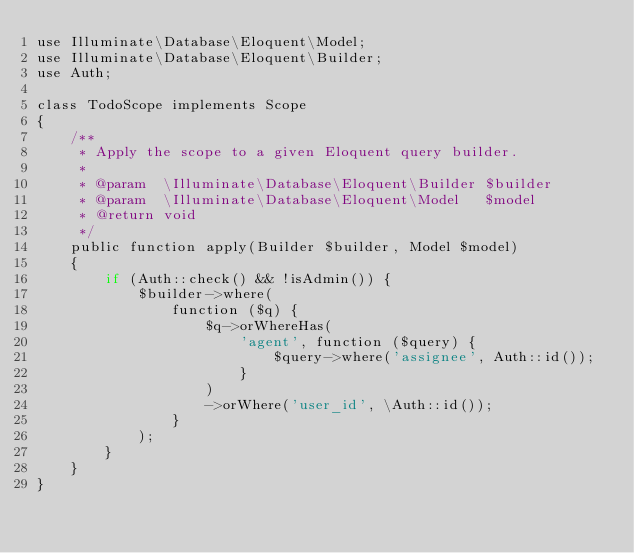Convert code to text. <code><loc_0><loc_0><loc_500><loc_500><_PHP_>use Illuminate\Database\Eloquent\Model;
use Illuminate\Database\Eloquent\Builder;
use Auth;

class TodoScope implements Scope
{
    /**
     * Apply the scope to a given Eloquent query builder.
     *
     * @param  \Illuminate\Database\Eloquent\Builder $builder
     * @param  \Illuminate\Database\Eloquent\Model   $model
     * @return void
     */
    public function apply(Builder $builder, Model $model)
    {
        if (Auth::check() && !isAdmin()) {
            $builder->where(
                function ($q) {
                    $q->orWhereHas(
                        'agent', function ($query) {
                            $query->where('assignee', Auth::id());
                        }
                    )
                    ->orWhere('user_id', \Auth::id());
                }
            );
        }
    }
}
</code> 